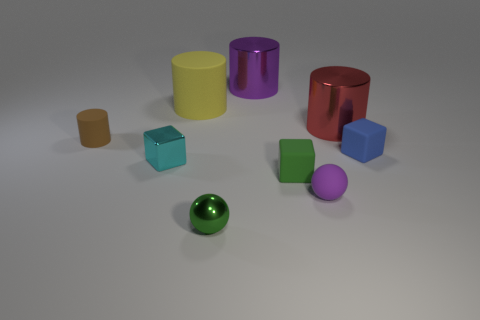Subtract 1 cylinders. How many cylinders are left? 3 Add 1 big yellow cylinders. How many objects exist? 10 Subtract all balls. How many objects are left? 7 Subtract all tiny purple rubber objects. Subtract all yellow metallic cubes. How many objects are left? 8 Add 5 green rubber blocks. How many green rubber blocks are left? 6 Add 1 balls. How many balls exist? 3 Subtract 0 cyan cylinders. How many objects are left? 9 